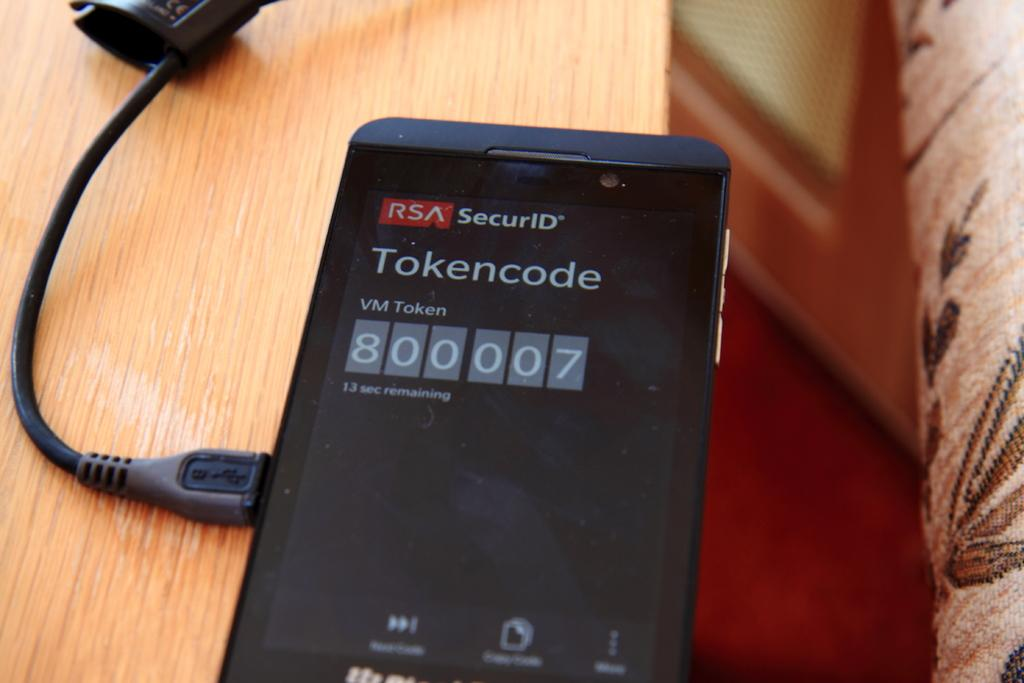Provide a one-sentence caption for the provided image. an electronic device with a tokencode on it. 